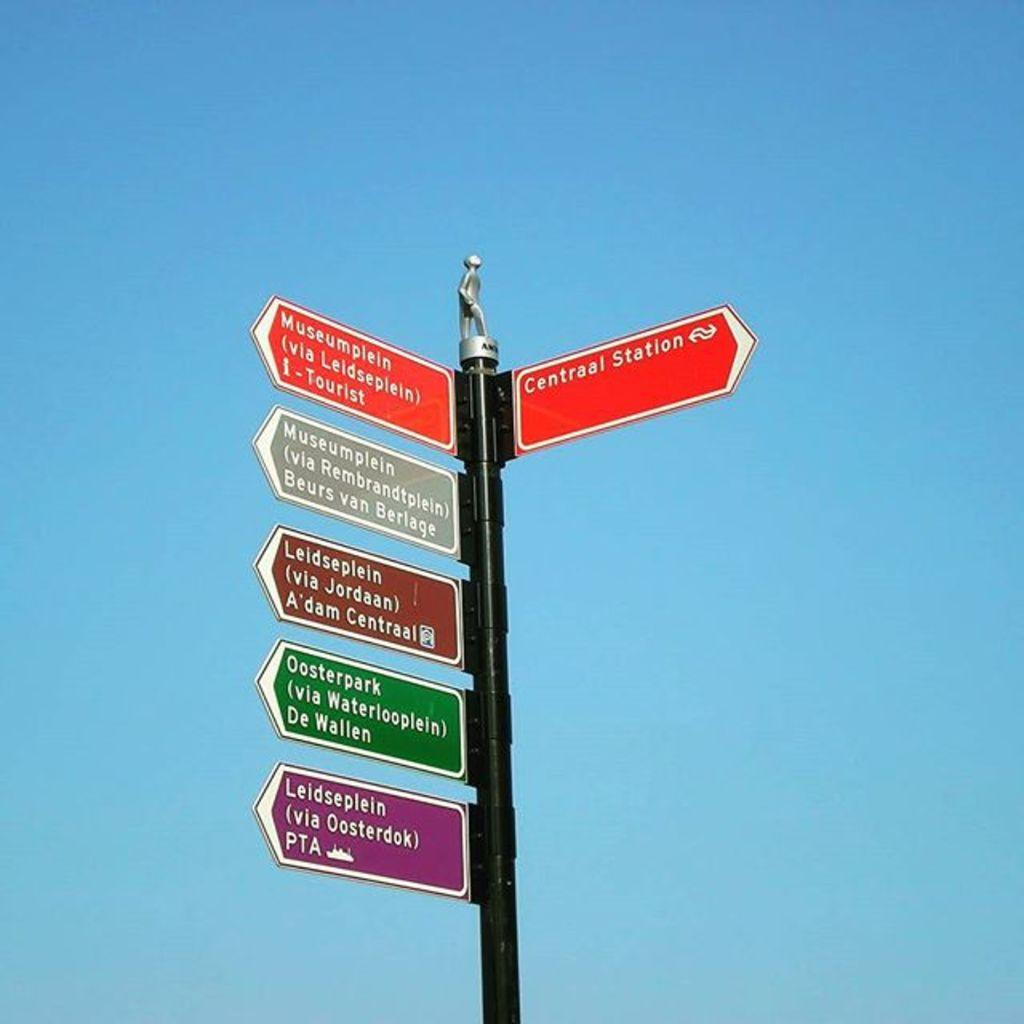<image>
Create a compact narrative representing the image presented. Several signs are on a post, including one for Centraal Station. 